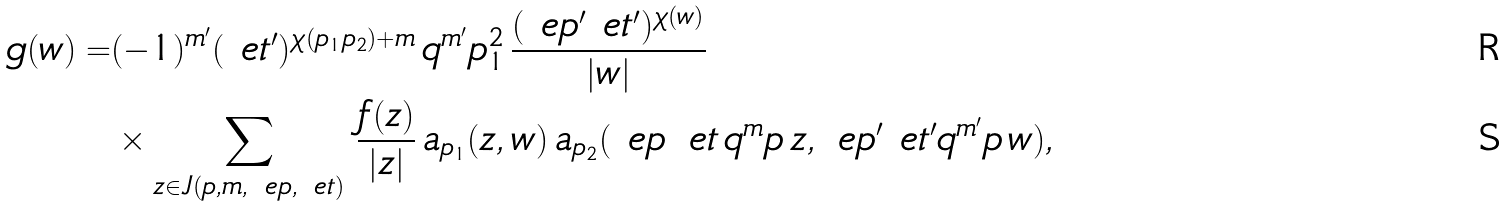<formula> <loc_0><loc_0><loc_500><loc_500>g ( w ) = & ( - 1 ) ^ { m ^ { \prime } } ( \ e t ^ { \prime } ) ^ { \chi ( p _ { 1 } p _ { 2 } ) + m } \, q ^ { m ^ { \prime } } p _ { 1 } ^ { 2 } \, \frac { ( \ e p ^ { \prime } \ e t ^ { \prime } ) ^ { \chi ( w ) } } { | w | } \\ & \times \sum _ { z \in J ( p , m , \ e p , \ e t ) } \, \frac { f ( z ) } { | z | } \, a _ { p _ { 1 } } ( z , w ) \, a _ { p _ { 2 } } ( \ e p \, \ e t \, q ^ { m } p \, z , \ e p ^ { \prime } \ e t ^ { \prime } q ^ { m ^ { \prime } } p \, w ) ,</formula> 